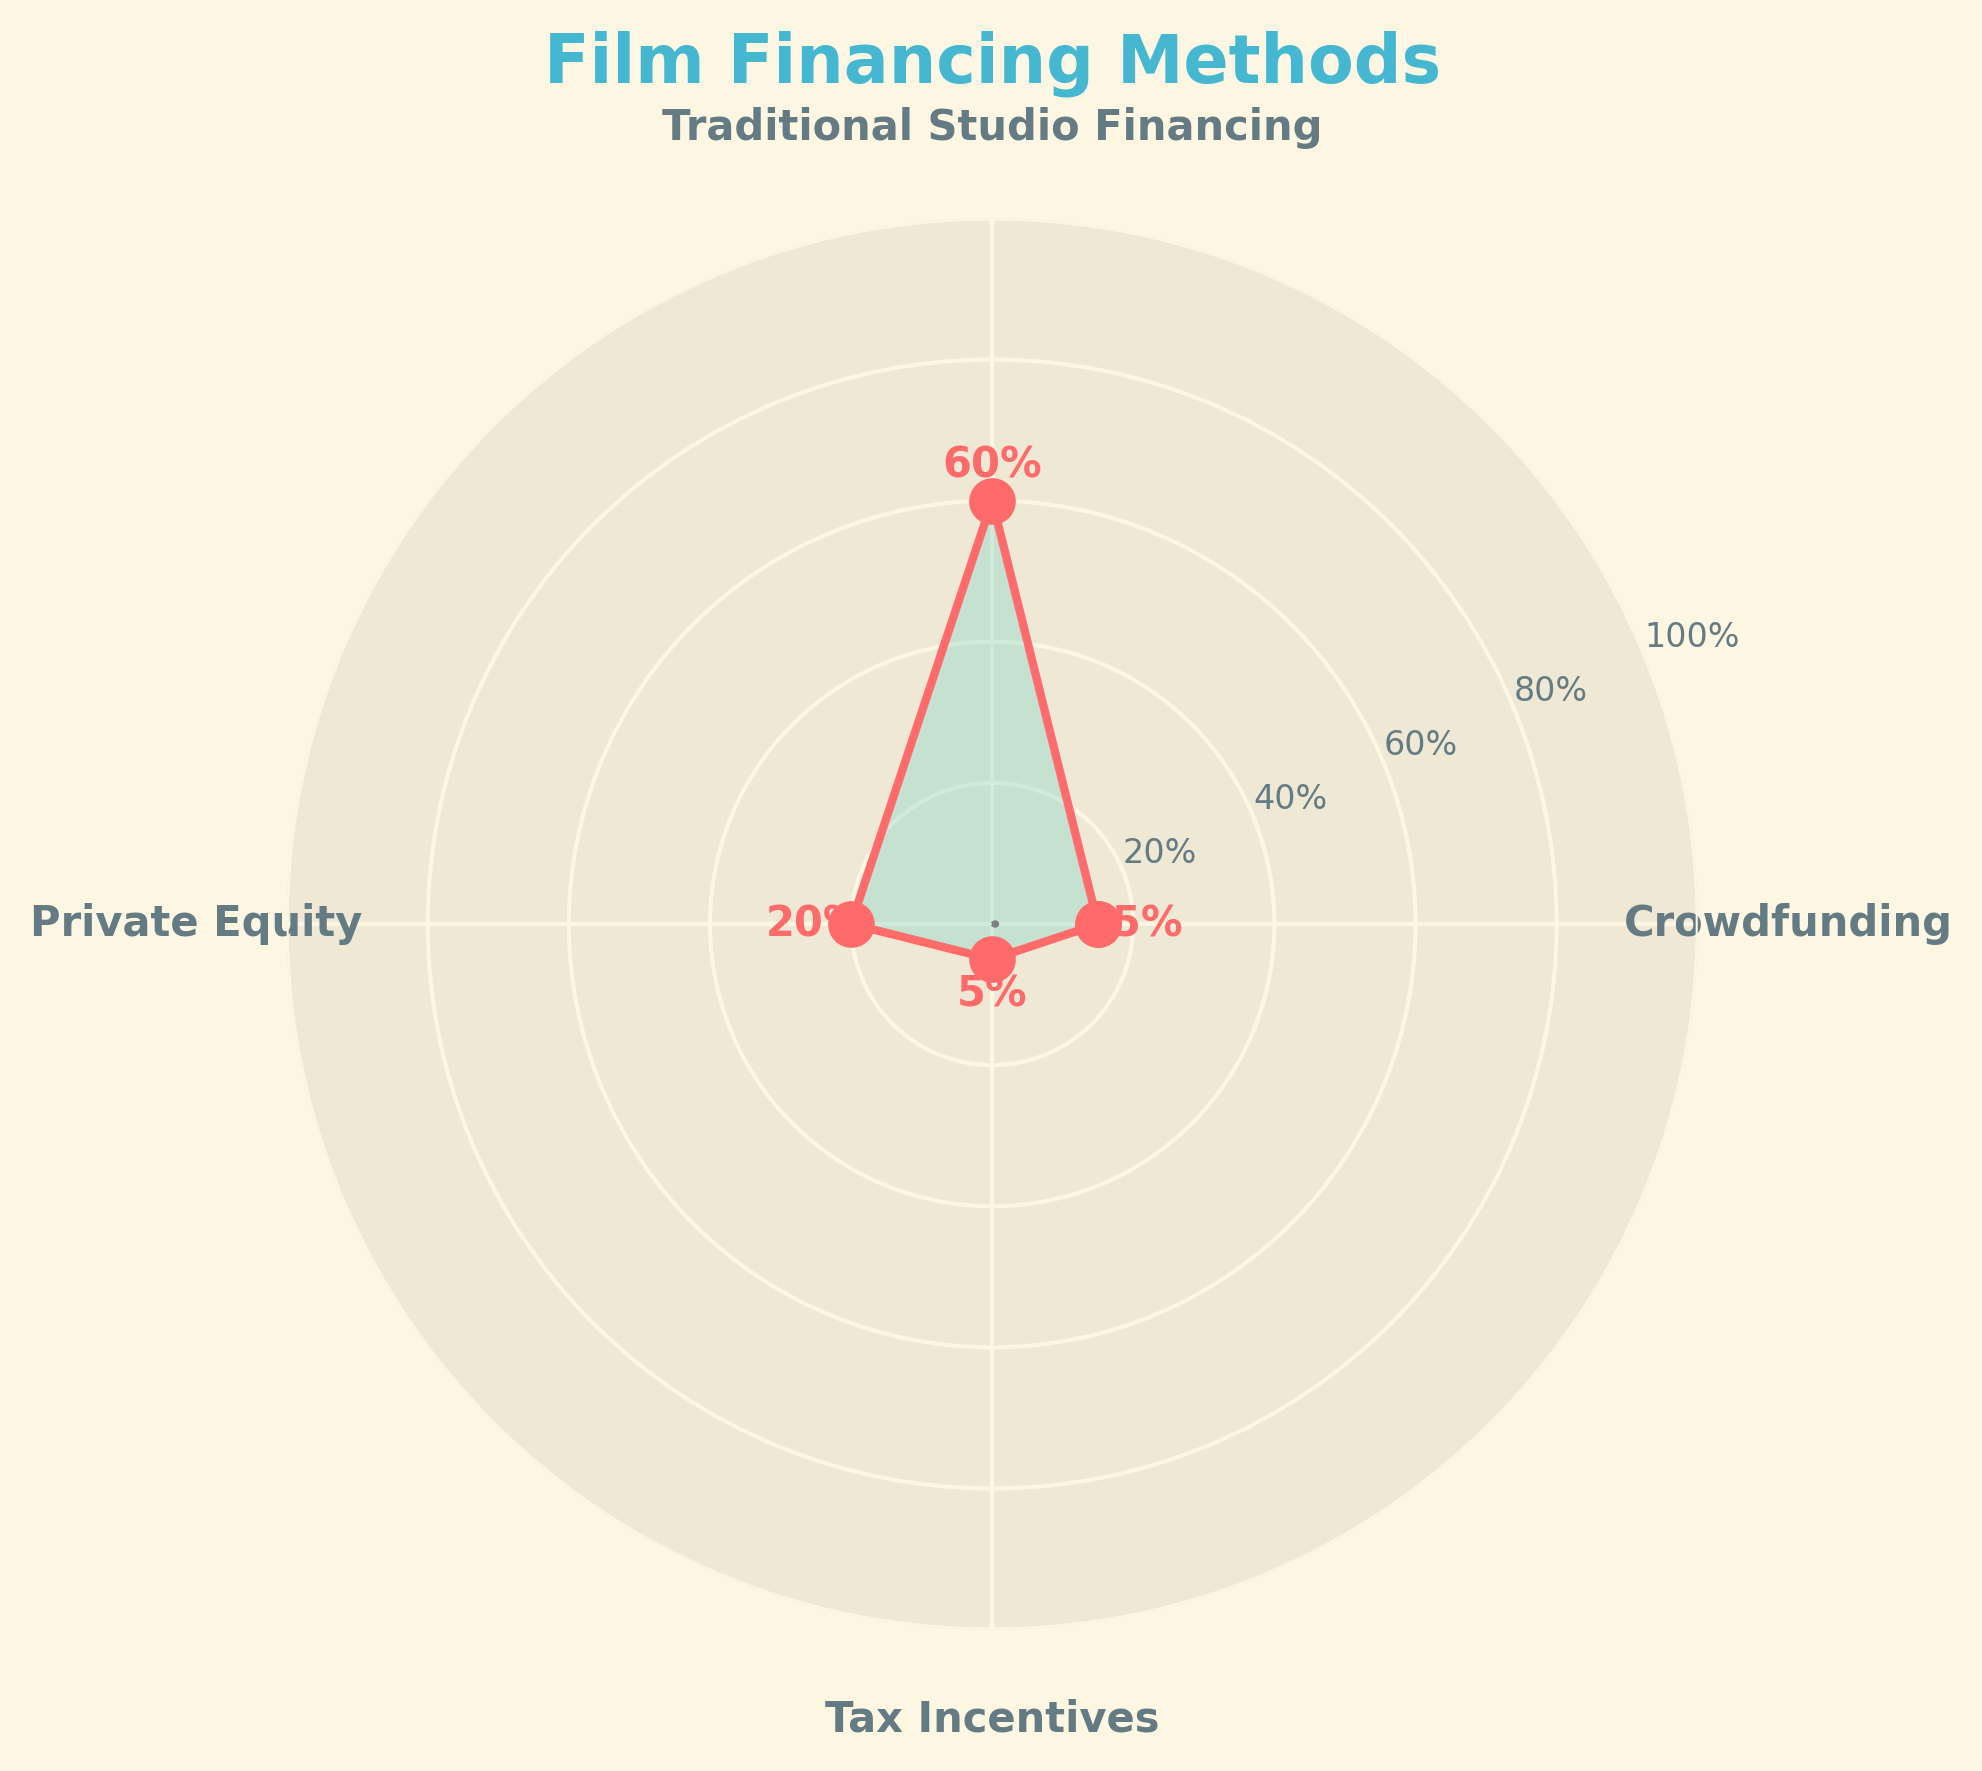How much percentage of film financing is provided by crowdfunding? The gauge chart shows the percentage of total film budget raised through different financing methods, with one segment labeled "Crowdfunding" indicating the specific percentage value. The value associated with "Crowdfunding" is 15%.
Answer: 15% What is the title of the chart? The title of the chart is located at the top center of the figure. It reads "Film Financing Methods".
Answer: Film Financing Methods Which financing method provides the highest percentage of the film budget? The chart lists several financing methods with their corresponding percentages. The highest percentage is labeled under "Traditional Studio Financing", which is 60%.
Answer: Traditional Studio Financing How many different financing methods are shown in the chart? By counting the labels present around the chart, we can see that there are four unique financing methods listed.
Answer: 4 What percentage of the film budget is provided by private equity? The sector labeled "Private Equity" is marked with its corresponding percentage. This value is 20%.
Answer: 20% What's the combined percentage of financing from Traditional Studio Financing and Crowdfunding? The chart provides the percentage for each method. Adding the percentages for "Traditional Studio Financing" (60%) and "Crowdfunding" (15%) gives us 60 + 15 = 75%.
Answer: 75% Compare the film budget percentage raised through crowdfunding to that raised through tax incentives. Which one is greater? The chart displays the percentages for both "Crowdfunding" and "Tax Incentives". Crowdfunding is at 15%, while Tax Incentives are at 5%. Therefore, crowdfunding is greater.
Answer: Crowdfunding What is the difference in percentage points between Traditional Studio Financing and Private Equity? The chart indicates that Traditional Studio Financing is 60% and Private Equity is 20%. Calculating the difference, we get 60 - 20 = 40 percentage points.
Answer: 40 Which two financing methods together account for less than half of the total film budget? Examining the percentages for each method, Crowdfunding (15%) and Tax Incentives (5%) together total 15 + 5 = 20%, which is less than 50%.
Answer: Crowdfunding and Tax Incentives What's the average percentage of the film budget raised from sources other than traditional studio financing? Adding the percentages for Crowdfunding, Private Equity, and Tax Incentives (15%, 20%, 5%) gives us 15 + 20 + 5 = 40. Dividing by the three sources, the average is 40 / 3 ≈ 13.33%.
Answer: 13.33% 